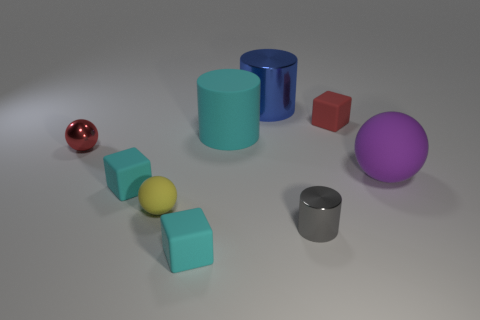Is the number of cyan rubber cylinders on the left side of the yellow object greater than the number of red shiny balls that are in front of the shiny ball?
Ensure brevity in your answer.  No. Does the red thing that is on the right side of the tiny yellow matte sphere have the same material as the large purple ball that is to the right of the yellow sphere?
Offer a very short reply. Yes. Are there any cylinders behind the red metal object?
Your response must be concise. Yes. How many brown things are either tiny shiny spheres or matte spheres?
Your answer should be very brief. 0. Is the large cyan object made of the same material as the thing in front of the small metal cylinder?
Ensure brevity in your answer.  Yes. There is a yellow rubber thing that is the same shape as the big purple matte thing; what is its size?
Make the answer very short. Small. What is the material of the cyan cylinder?
Make the answer very short. Rubber. What is the material of the sphere that is to the right of the red thing that is right of the cylinder that is right of the large metal object?
Make the answer very short. Rubber. There is a red object that is right of the large cyan cylinder; is it the same size as the cyan block that is in front of the yellow rubber object?
Keep it short and to the point. Yes. How many other objects are the same material as the small red cube?
Provide a succinct answer. 5. 